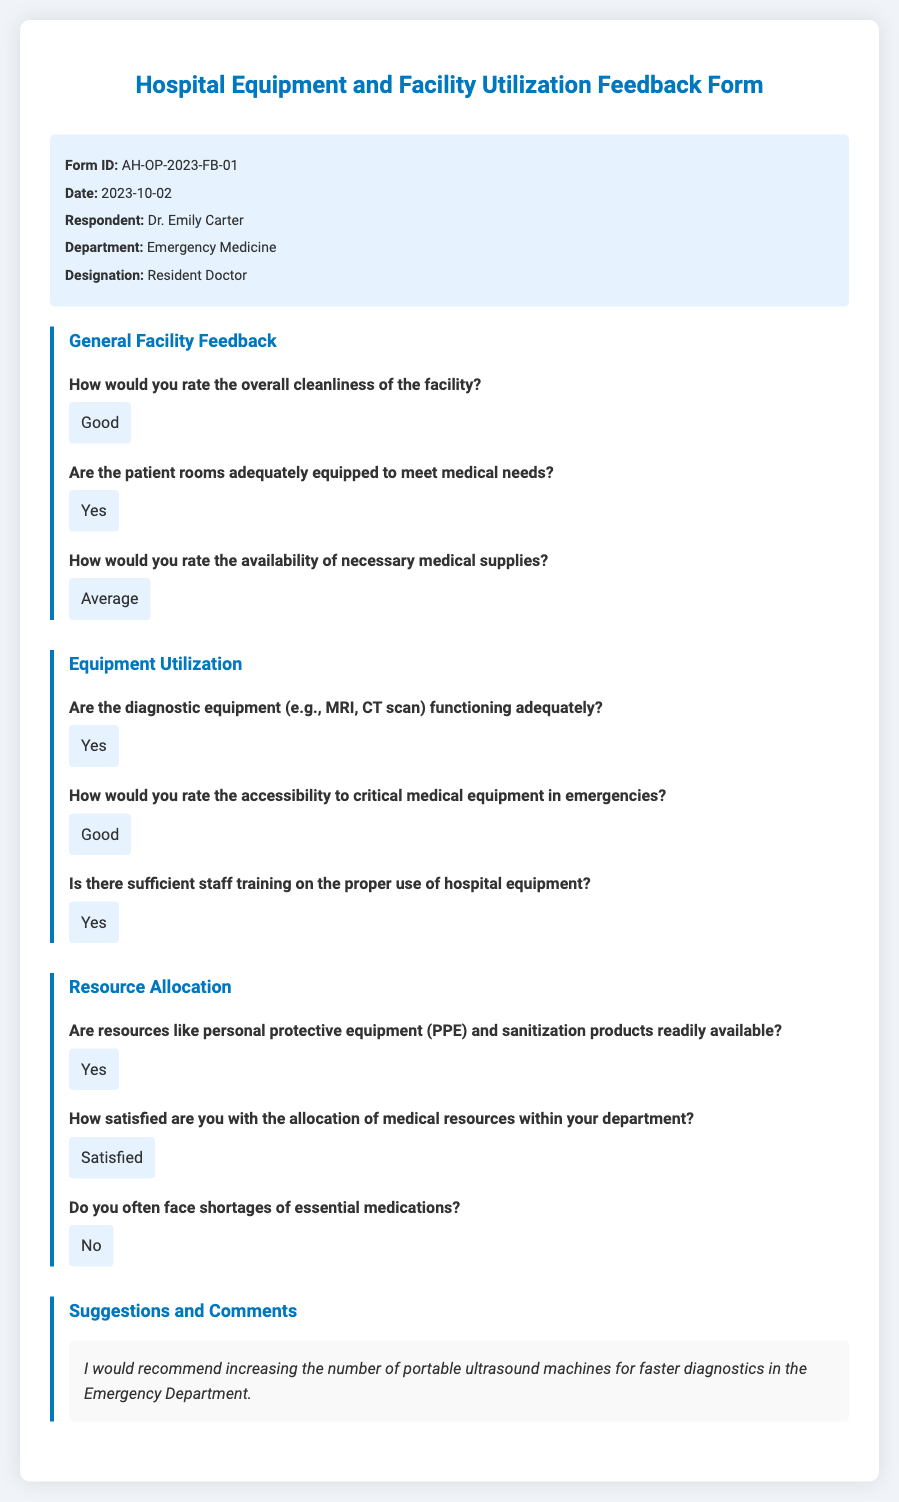What is the Form ID? The Form ID is listed at the top of the document as a unique identifier for this feedback form.
Answer: AH-OP-2023-FB-01 Who is the respondent? The respondent's name is provided in the form header section, which identifies the person filling out the questionnaire.
Answer: Dr. Emily Carter What is the date of the form? The date is specified in the form header and indicates when the feedback was submitted.
Answer: 2023-10-02 How would you rate the overall cleanliness of the facility? This question asks for the respondent's opinion about the facility's cleanliness, which is directly answered in the feedback.
Answer: Good Are the diagnostic equipment functioning adequately? This question assesses the operational status of critical diagnostic tools, which is answered in the document.
Answer: Yes How satisfied are you with the allocation of medical resources within your department? This question focuses on the respondent's satisfaction level regarding resource allocation, which is stated in the feedback.
Answer: Satisfied What specific recommendation was made in the comments section? The comments section includes the respondent's suggestions on improving the facility or equipment, which can be found in the detailed feedback.
Answer: Increasing the number of portable ultrasound machines for faster diagnostics in the Emergency Department Is there sufficient staff training on the proper use of hospital equipment? This question checks for the respondent's view on staff training, which is answered affirmatively in the feedback.
Answer: Yes 